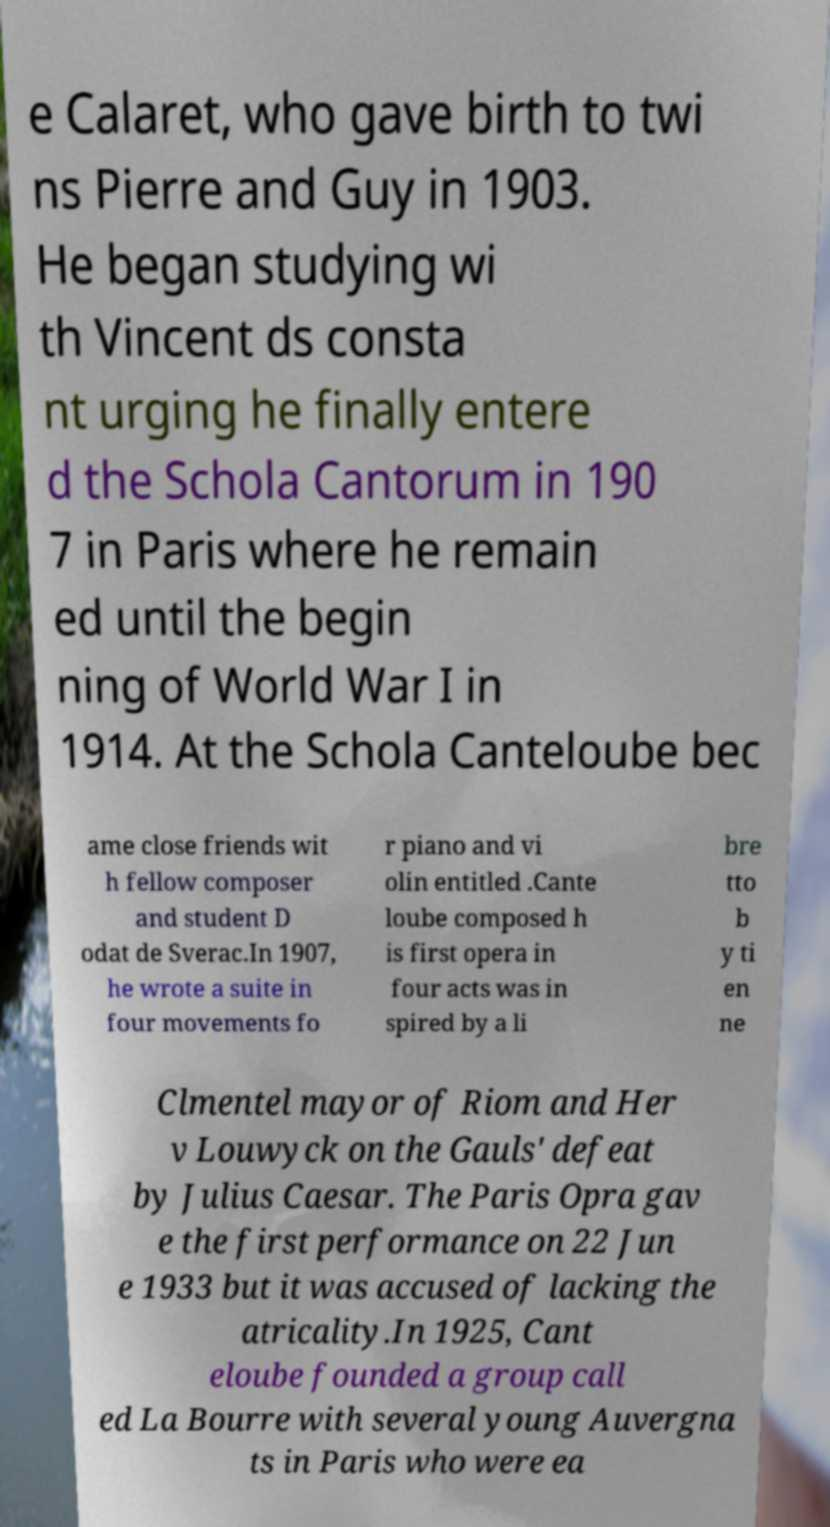Can you read and provide the text displayed in the image?This photo seems to have some interesting text. Can you extract and type it out for me? e Calaret, who gave birth to twi ns Pierre and Guy in 1903. He began studying wi th Vincent ds consta nt urging he finally entere d the Schola Cantorum in 190 7 in Paris where he remain ed until the begin ning of World War I in 1914. At the Schola Canteloube bec ame close friends wit h fellow composer and student D odat de Sverac.In 1907, he wrote a suite in four movements fo r piano and vi olin entitled .Cante loube composed h is first opera in four acts was in spired by a li bre tto b y ti en ne Clmentel mayor of Riom and Her v Louwyck on the Gauls' defeat by Julius Caesar. The Paris Opra gav e the first performance on 22 Jun e 1933 but it was accused of lacking the atricality.In 1925, Cant eloube founded a group call ed La Bourre with several young Auvergna ts in Paris who were ea 